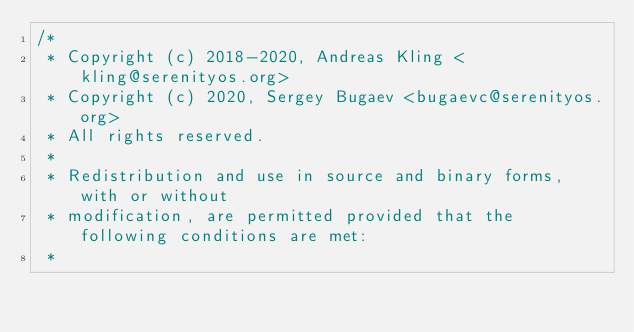<code> <loc_0><loc_0><loc_500><loc_500><_C++_>/*
 * Copyright (c) 2018-2020, Andreas Kling <kling@serenityos.org>
 * Copyright (c) 2020, Sergey Bugaev <bugaevc@serenityos.org>
 * All rights reserved.
 *
 * Redistribution and use in source and binary forms, with or without
 * modification, are permitted provided that the following conditions are met:
 *</code> 